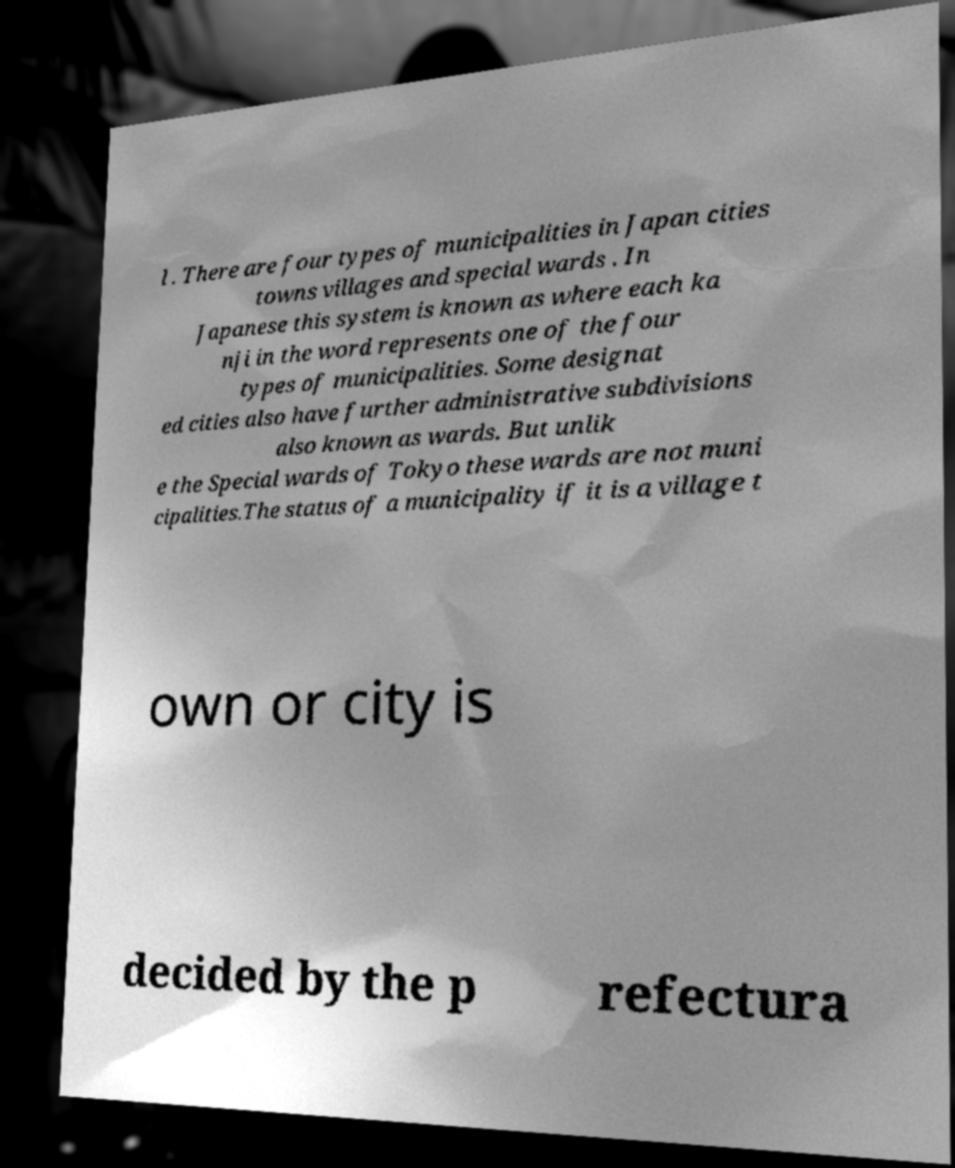Please read and relay the text visible in this image. What does it say? l . There are four types of municipalities in Japan cities towns villages and special wards . In Japanese this system is known as where each ka nji in the word represents one of the four types of municipalities. Some designat ed cities also have further administrative subdivisions also known as wards. But unlik e the Special wards of Tokyo these wards are not muni cipalities.The status of a municipality if it is a village t own or city is decided by the p refectura 